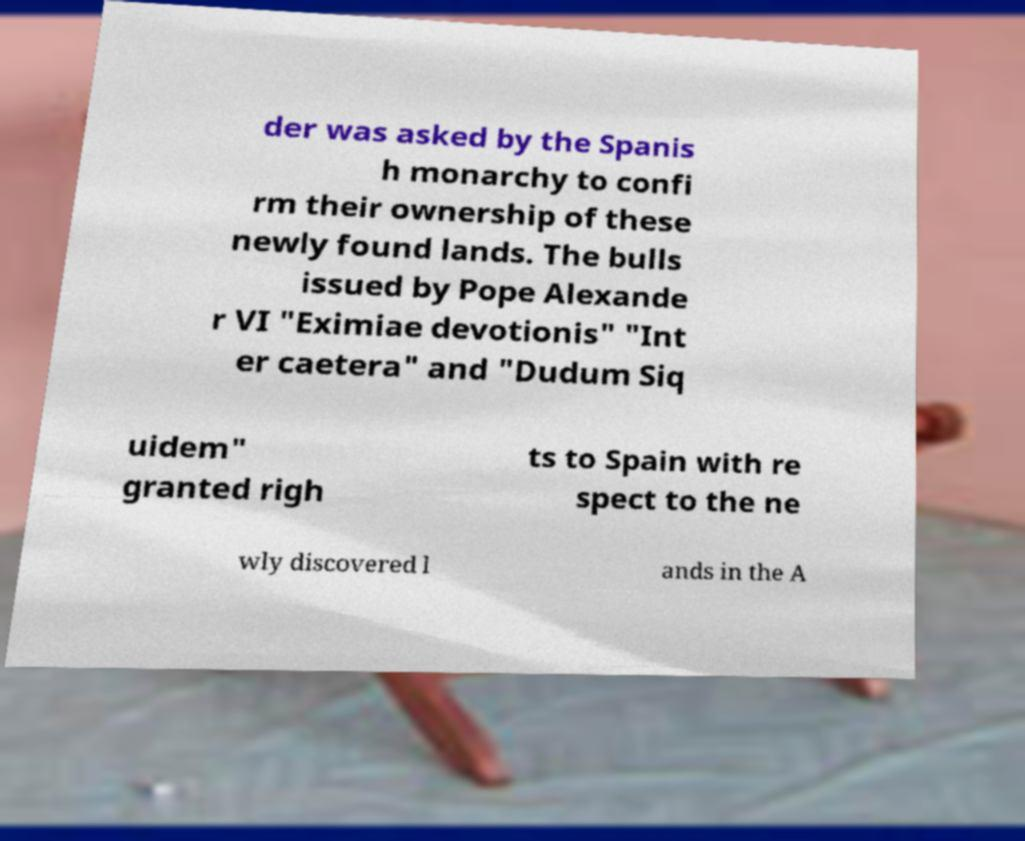What messages or text are displayed in this image? I need them in a readable, typed format. der was asked by the Spanis h monarchy to confi rm their ownership of these newly found lands. The bulls issued by Pope Alexande r VI "Eximiae devotionis" "Int er caetera" and "Dudum Siq uidem" granted righ ts to Spain with re spect to the ne wly discovered l ands in the A 